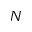Convert formula to latex. <formula><loc_0><loc_0><loc_500><loc_500>N</formula> 